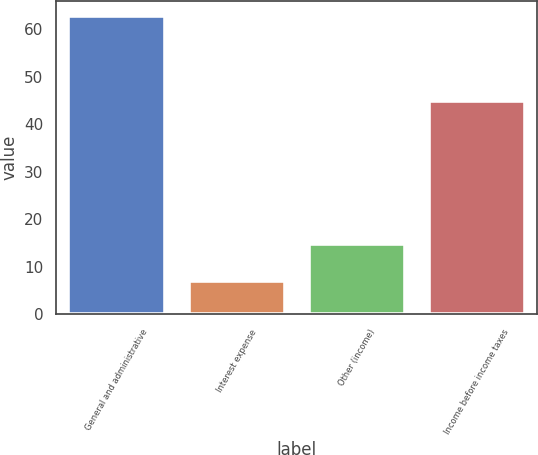Convert chart to OTSL. <chart><loc_0><loc_0><loc_500><loc_500><bar_chart><fcel>General and administrative<fcel>Interest expense<fcel>Other (income)<fcel>Income before income taxes<nl><fcel>62.8<fcel>7.1<fcel>14.8<fcel>44.9<nl></chart> 